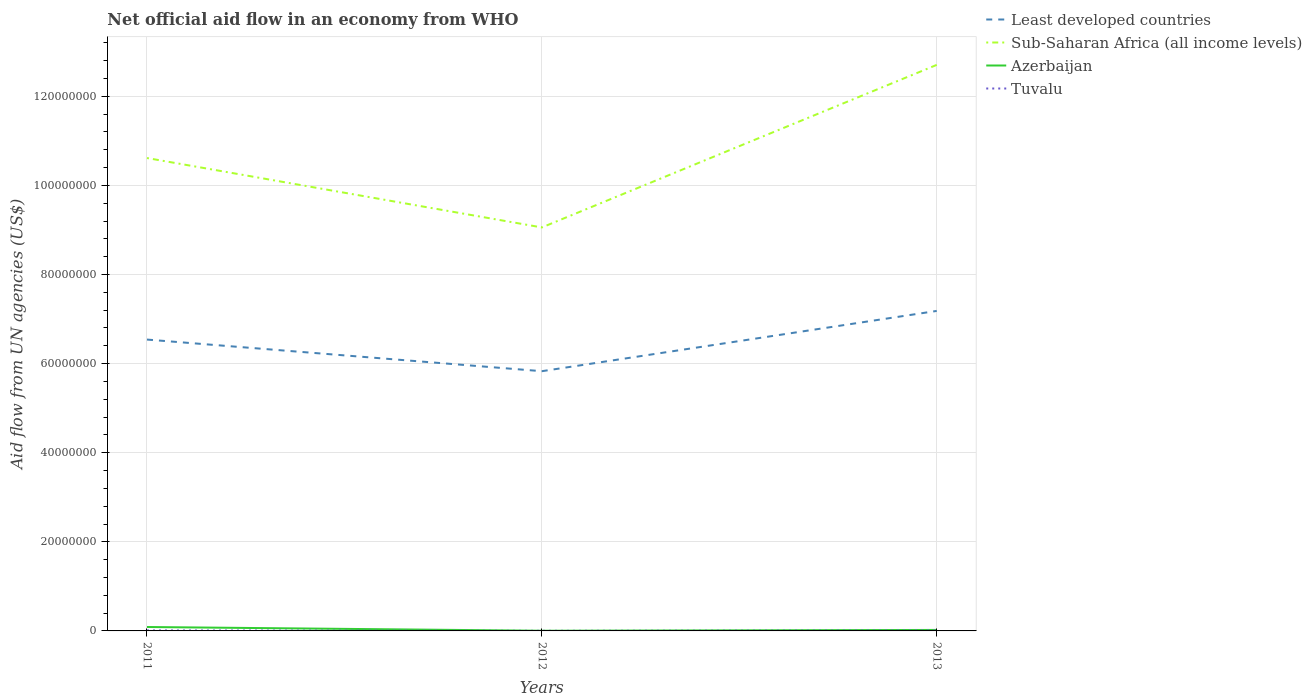In which year was the net official aid flow in Tuvalu maximum?
Give a very brief answer. 2012. What is the total net official aid flow in Least developed countries in the graph?
Offer a terse response. -1.35e+07. What is the difference between the highest and the second highest net official aid flow in Least developed countries?
Ensure brevity in your answer.  1.35e+07. What is the difference between the highest and the lowest net official aid flow in Least developed countries?
Your response must be concise. 2. What is the difference between two consecutive major ticks on the Y-axis?
Keep it short and to the point. 2.00e+07. Are the values on the major ticks of Y-axis written in scientific E-notation?
Provide a short and direct response. No. Does the graph contain any zero values?
Ensure brevity in your answer.  No. Does the graph contain grids?
Your answer should be compact. Yes. How many legend labels are there?
Your answer should be very brief. 4. How are the legend labels stacked?
Your answer should be very brief. Vertical. What is the title of the graph?
Ensure brevity in your answer.  Net official aid flow in an economy from WHO. Does "Tonga" appear as one of the legend labels in the graph?
Your answer should be very brief. No. What is the label or title of the Y-axis?
Give a very brief answer. Aid flow from UN agencies (US$). What is the Aid flow from UN agencies (US$) in Least developed countries in 2011?
Your answer should be very brief. 6.54e+07. What is the Aid flow from UN agencies (US$) of Sub-Saharan Africa (all income levels) in 2011?
Ensure brevity in your answer.  1.06e+08. What is the Aid flow from UN agencies (US$) of Azerbaijan in 2011?
Offer a very short reply. 8.80e+05. What is the Aid flow from UN agencies (US$) in Least developed countries in 2012?
Offer a very short reply. 5.83e+07. What is the Aid flow from UN agencies (US$) of Sub-Saharan Africa (all income levels) in 2012?
Give a very brief answer. 9.06e+07. What is the Aid flow from UN agencies (US$) of Azerbaijan in 2012?
Keep it short and to the point. 4.00e+04. What is the Aid flow from UN agencies (US$) in Least developed countries in 2013?
Give a very brief answer. 7.18e+07. What is the Aid flow from UN agencies (US$) in Sub-Saharan Africa (all income levels) in 2013?
Your response must be concise. 1.27e+08. What is the Aid flow from UN agencies (US$) in Azerbaijan in 2013?
Your answer should be very brief. 2.20e+05. What is the Aid flow from UN agencies (US$) of Tuvalu in 2013?
Your answer should be very brief. 9.00e+04. Across all years, what is the maximum Aid flow from UN agencies (US$) in Least developed countries?
Provide a succinct answer. 7.18e+07. Across all years, what is the maximum Aid flow from UN agencies (US$) in Sub-Saharan Africa (all income levels)?
Ensure brevity in your answer.  1.27e+08. Across all years, what is the maximum Aid flow from UN agencies (US$) of Azerbaijan?
Provide a short and direct response. 8.80e+05. Across all years, what is the maximum Aid flow from UN agencies (US$) in Tuvalu?
Make the answer very short. 1.10e+05. Across all years, what is the minimum Aid flow from UN agencies (US$) of Least developed countries?
Ensure brevity in your answer.  5.83e+07. Across all years, what is the minimum Aid flow from UN agencies (US$) in Sub-Saharan Africa (all income levels)?
Give a very brief answer. 9.06e+07. Across all years, what is the minimum Aid flow from UN agencies (US$) of Azerbaijan?
Make the answer very short. 4.00e+04. What is the total Aid flow from UN agencies (US$) in Least developed countries in the graph?
Offer a terse response. 1.96e+08. What is the total Aid flow from UN agencies (US$) of Sub-Saharan Africa (all income levels) in the graph?
Keep it short and to the point. 3.24e+08. What is the total Aid flow from UN agencies (US$) of Azerbaijan in the graph?
Offer a very short reply. 1.14e+06. What is the total Aid flow from UN agencies (US$) in Tuvalu in the graph?
Give a very brief answer. 2.20e+05. What is the difference between the Aid flow from UN agencies (US$) of Least developed countries in 2011 and that in 2012?
Offer a very short reply. 7.10e+06. What is the difference between the Aid flow from UN agencies (US$) in Sub-Saharan Africa (all income levels) in 2011 and that in 2012?
Give a very brief answer. 1.56e+07. What is the difference between the Aid flow from UN agencies (US$) in Azerbaijan in 2011 and that in 2012?
Your answer should be compact. 8.40e+05. What is the difference between the Aid flow from UN agencies (US$) in Least developed countries in 2011 and that in 2013?
Your response must be concise. -6.43e+06. What is the difference between the Aid flow from UN agencies (US$) of Sub-Saharan Africa (all income levels) in 2011 and that in 2013?
Your response must be concise. -2.09e+07. What is the difference between the Aid flow from UN agencies (US$) in Least developed countries in 2012 and that in 2013?
Keep it short and to the point. -1.35e+07. What is the difference between the Aid flow from UN agencies (US$) of Sub-Saharan Africa (all income levels) in 2012 and that in 2013?
Offer a very short reply. -3.65e+07. What is the difference between the Aid flow from UN agencies (US$) of Least developed countries in 2011 and the Aid flow from UN agencies (US$) of Sub-Saharan Africa (all income levels) in 2012?
Provide a succinct answer. -2.52e+07. What is the difference between the Aid flow from UN agencies (US$) of Least developed countries in 2011 and the Aid flow from UN agencies (US$) of Azerbaijan in 2012?
Offer a very short reply. 6.54e+07. What is the difference between the Aid flow from UN agencies (US$) of Least developed countries in 2011 and the Aid flow from UN agencies (US$) of Tuvalu in 2012?
Provide a short and direct response. 6.54e+07. What is the difference between the Aid flow from UN agencies (US$) of Sub-Saharan Africa (all income levels) in 2011 and the Aid flow from UN agencies (US$) of Azerbaijan in 2012?
Offer a terse response. 1.06e+08. What is the difference between the Aid flow from UN agencies (US$) in Sub-Saharan Africa (all income levels) in 2011 and the Aid flow from UN agencies (US$) in Tuvalu in 2012?
Your answer should be compact. 1.06e+08. What is the difference between the Aid flow from UN agencies (US$) in Azerbaijan in 2011 and the Aid flow from UN agencies (US$) in Tuvalu in 2012?
Make the answer very short. 8.60e+05. What is the difference between the Aid flow from UN agencies (US$) in Least developed countries in 2011 and the Aid flow from UN agencies (US$) in Sub-Saharan Africa (all income levels) in 2013?
Your answer should be compact. -6.17e+07. What is the difference between the Aid flow from UN agencies (US$) of Least developed countries in 2011 and the Aid flow from UN agencies (US$) of Azerbaijan in 2013?
Offer a very short reply. 6.52e+07. What is the difference between the Aid flow from UN agencies (US$) in Least developed countries in 2011 and the Aid flow from UN agencies (US$) in Tuvalu in 2013?
Offer a very short reply. 6.53e+07. What is the difference between the Aid flow from UN agencies (US$) of Sub-Saharan Africa (all income levels) in 2011 and the Aid flow from UN agencies (US$) of Azerbaijan in 2013?
Ensure brevity in your answer.  1.06e+08. What is the difference between the Aid flow from UN agencies (US$) of Sub-Saharan Africa (all income levels) in 2011 and the Aid flow from UN agencies (US$) of Tuvalu in 2013?
Make the answer very short. 1.06e+08. What is the difference between the Aid flow from UN agencies (US$) in Azerbaijan in 2011 and the Aid flow from UN agencies (US$) in Tuvalu in 2013?
Keep it short and to the point. 7.90e+05. What is the difference between the Aid flow from UN agencies (US$) in Least developed countries in 2012 and the Aid flow from UN agencies (US$) in Sub-Saharan Africa (all income levels) in 2013?
Your response must be concise. -6.88e+07. What is the difference between the Aid flow from UN agencies (US$) of Least developed countries in 2012 and the Aid flow from UN agencies (US$) of Azerbaijan in 2013?
Make the answer very short. 5.81e+07. What is the difference between the Aid flow from UN agencies (US$) of Least developed countries in 2012 and the Aid flow from UN agencies (US$) of Tuvalu in 2013?
Offer a terse response. 5.82e+07. What is the difference between the Aid flow from UN agencies (US$) of Sub-Saharan Africa (all income levels) in 2012 and the Aid flow from UN agencies (US$) of Azerbaijan in 2013?
Make the answer very short. 9.04e+07. What is the difference between the Aid flow from UN agencies (US$) of Sub-Saharan Africa (all income levels) in 2012 and the Aid flow from UN agencies (US$) of Tuvalu in 2013?
Give a very brief answer. 9.05e+07. What is the difference between the Aid flow from UN agencies (US$) in Azerbaijan in 2012 and the Aid flow from UN agencies (US$) in Tuvalu in 2013?
Your answer should be very brief. -5.00e+04. What is the average Aid flow from UN agencies (US$) of Least developed countries per year?
Your answer should be compact. 6.52e+07. What is the average Aid flow from UN agencies (US$) in Sub-Saharan Africa (all income levels) per year?
Make the answer very short. 1.08e+08. What is the average Aid flow from UN agencies (US$) in Tuvalu per year?
Make the answer very short. 7.33e+04. In the year 2011, what is the difference between the Aid flow from UN agencies (US$) of Least developed countries and Aid flow from UN agencies (US$) of Sub-Saharan Africa (all income levels)?
Keep it short and to the point. -4.08e+07. In the year 2011, what is the difference between the Aid flow from UN agencies (US$) in Least developed countries and Aid flow from UN agencies (US$) in Azerbaijan?
Your response must be concise. 6.45e+07. In the year 2011, what is the difference between the Aid flow from UN agencies (US$) in Least developed countries and Aid flow from UN agencies (US$) in Tuvalu?
Ensure brevity in your answer.  6.53e+07. In the year 2011, what is the difference between the Aid flow from UN agencies (US$) of Sub-Saharan Africa (all income levels) and Aid flow from UN agencies (US$) of Azerbaijan?
Your response must be concise. 1.05e+08. In the year 2011, what is the difference between the Aid flow from UN agencies (US$) of Sub-Saharan Africa (all income levels) and Aid flow from UN agencies (US$) of Tuvalu?
Keep it short and to the point. 1.06e+08. In the year 2011, what is the difference between the Aid flow from UN agencies (US$) of Azerbaijan and Aid flow from UN agencies (US$) of Tuvalu?
Keep it short and to the point. 7.70e+05. In the year 2012, what is the difference between the Aid flow from UN agencies (US$) in Least developed countries and Aid flow from UN agencies (US$) in Sub-Saharan Africa (all income levels)?
Make the answer very short. -3.23e+07. In the year 2012, what is the difference between the Aid flow from UN agencies (US$) of Least developed countries and Aid flow from UN agencies (US$) of Azerbaijan?
Provide a succinct answer. 5.83e+07. In the year 2012, what is the difference between the Aid flow from UN agencies (US$) in Least developed countries and Aid flow from UN agencies (US$) in Tuvalu?
Give a very brief answer. 5.83e+07. In the year 2012, what is the difference between the Aid flow from UN agencies (US$) in Sub-Saharan Africa (all income levels) and Aid flow from UN agencies (US$) in Azerbaijan?
Offer a very short reply. 9.05e+07. In the year 2012, what is the difference between the Aid flow from UN agencies (US$) in Sub-Saharan Africa (all income levels) and Aid flow from UN agencies (US$) in Tuvalu?
Your answer should be very brief. 9.06e+07. In the year 2012, what is the difference between the Aid flow from UN agencies (US$) of Azerbaijan and Aid flow from UN agencies (US$) of Tuvalu?
Provide a short and direct response. 2.00e+04. In the year 2013, what is the difference between the Aid flow from UN agencies (US$) of Least developed countries and Aid flow from UN agencies (US$) of Sub-Saharan Africa (all income levels)?
Your answer should be compact. -5.52e+07. In the year 2013, what is the difference between the Aid flow from UN agencies (US$) in Least developed countries and Aid flow from UN agencies (US$) in Azerbaijan?
Make the answer very short. 7.16e+07. In the year 2013, what is the difference between the Aid flow from UN agencies (US$) in Least developed countries and Aid flow from UN agencies (US$) in Tuvalu?
Make the answer very short. 7.17e+07. In the year 2013, what is the difference between the Aid flow from UN agencies (US$) of Sub-Saharan Africa (all income levels) and Aid flow from UN agencies (US$) of Azerbaijan?
Give a very brief answer. 1.27e+08. In the year 2013, what is the difference between the Aid flow from UN agencies (US$) in Sub-Saharan Africa (all income levels) and Aid flow from UN agencies (US$) in Tuvalu?
Provide a succinct answer. 1.27e+08. In the year 2013, what is the difference between the Aid flow from UN agencies (US$) of Azerbaijan and Aid flow from UN agencies (US$) of Tuvalu?
Your response must be concise. 1.30e+05. What is the ratio of the Aid flow from UN agencies (US$) of Least developed countries in 2011 to that in 2012?
Make the answer very short. 1.12. What is the ratio of the Aid flow from UN agencies (US$) in Sub-Saharan Africa (all income levels) in 2011 to that in 2012?
Offer a terse response. 1.17. What is the ratio of the Aid flow from UN agencies (US$) of Tuvalu in 2011 to that in 2012?
Give a very brief answer. 5.5. What is the ratio of the Aid flow from UN agencies (US$) of Least developed countries in 2011 to that in 2013?
Provide a succinct answer. 0.91. What is the ratio of the Aid flow from UN agencies (US$) of Sub-Saharan Africa (all income levels) in 2011 to that in 2013?
Give a very brief answer. 0.84. What is the ratio of the Aid flow from UN agencies (US$) of Tuvalu in 2011 to that in 2013?
Your response must be concise. 1.22. What is the ratio of the Aid flow from UN agencies (US$) of Least developed countries in 2012 to that in 2013?
Provide a succinct answer. 0.81. What is the ratio of the Aid flow from UN agencies (US$) of Sub-Saharan Africa (all income levels) in 2012 to that in 2013?
Make the answer very short. 0.71. What is the ratio of the Aid flow from UN agencies (US$) of Azerbaijan in 2012 to that in 2013?
Make the answer very short. 0.18. What is the ratio of the Aid flow from UN agencies (US$) in Tuvalu in 2012 to that in 2013?
Your response must be concise. 0.22. What is the difference between the highest and the second highest Aid flow from UN agencies (US$) in Least developed countries?
Give a very brief answer. 6.43e+06. What is the difference between the highest and the second highest Aid flow from UN agencies (US$) of Sub-Saharan Africa (all income levels)?
Keep it short and to the point. 2.09e+07. What is the difference between the highest and the lowest Aid flow from UN agencies (US$) in Least developed countries?
Offer a very short reply. 1.35e+07. What is the difference between the highest and the lowest Aid flow from UN agencies (US$) of Sub-Saharan Africa (all income levels)?
Provide a succinct answer. 3.65e+07. What is the difference between the highest and the lowest Aid flow from UN agencies (US$) of Azerbaijan?
Your answer should be very brief. 8.40e+05. 